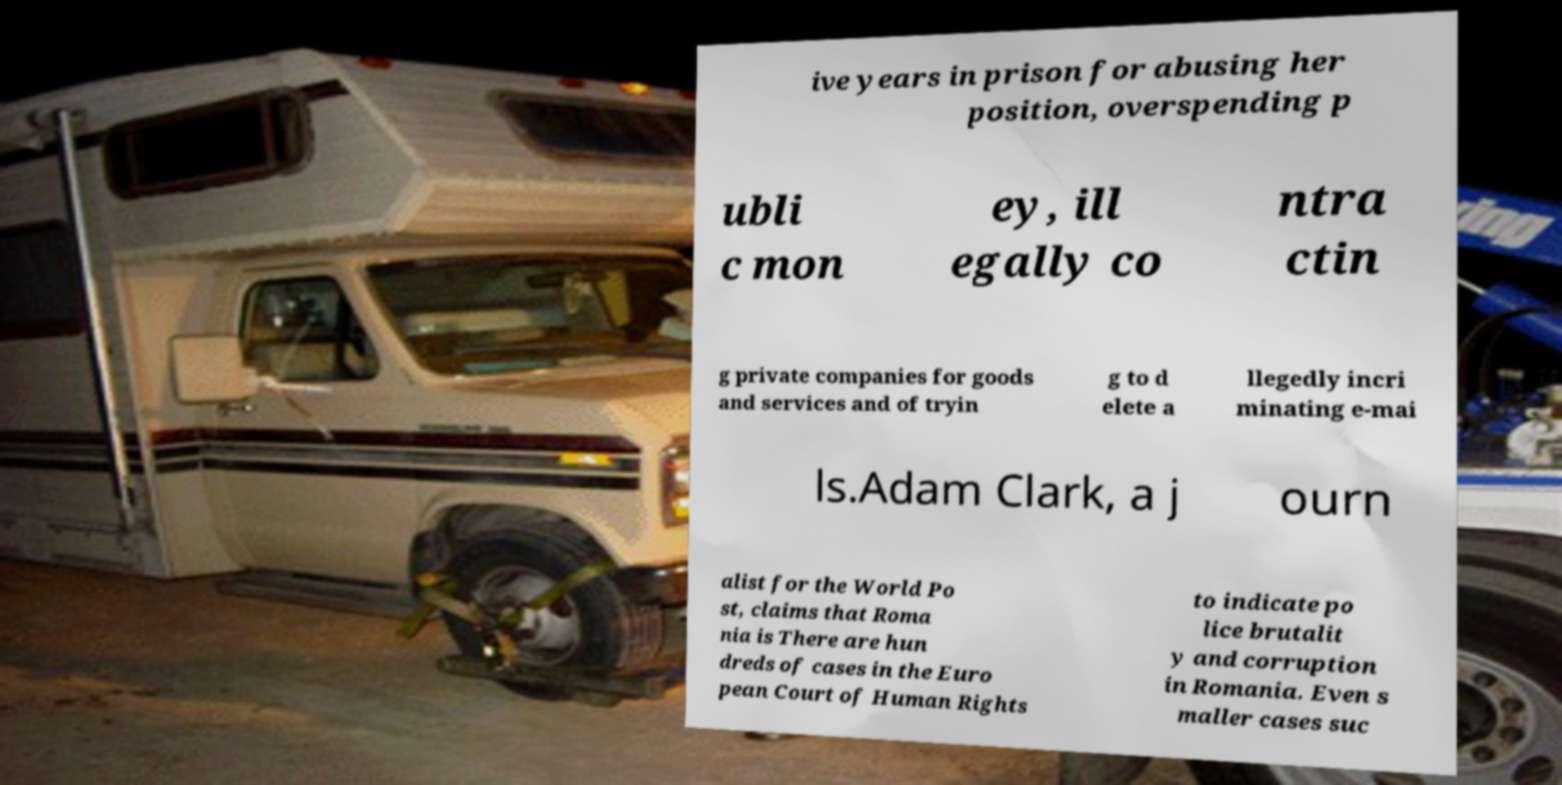I need the written content from this picture converted into text. Can you do that? ive years in prison for abusing her position, overspending p ubli c mon ey, ill egally co ntra ctin g private companies for goods and services and of tryin g to d elete a llegedly incri minating e-mai ls.Adam Clark, a j ourn alist for the World Po st, claims that Roma nia is There are hun dreds of cases in the Euro pean Court of Human Rights to indicate po lice brutalit y and corruption in Romania. Even s maller cases suc 